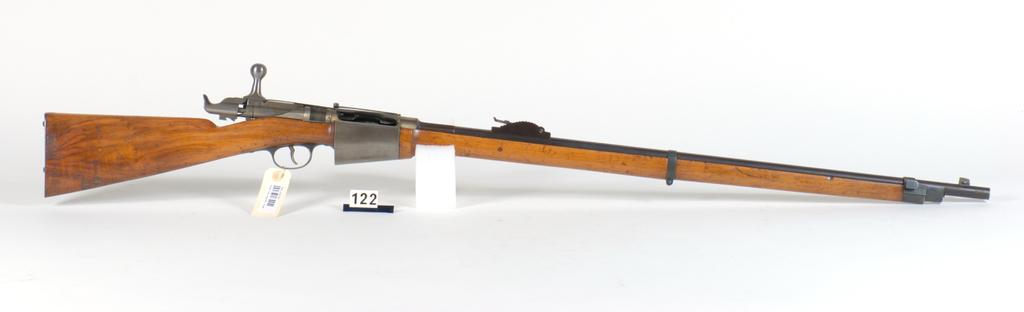What object in the image is typically used for self-defense or hunting? There is a gun in the image, which is typically used for self-defense or hunting. What type of label is present on the object in the image? There is a tag with a bar code in the image. Can you see your aunt standing next to the moon in the image? There is no aunt or moon present in the image. What type of fire is visible in the image? There is no fire present in the image. 